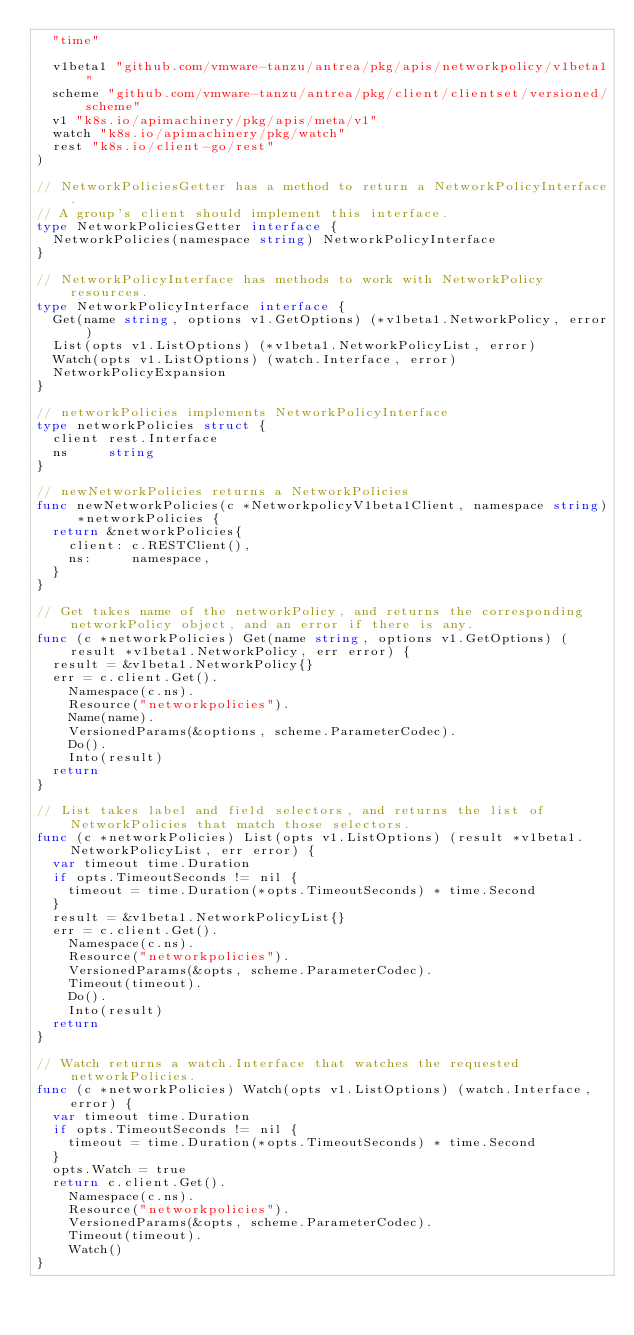<code> <loc_0><loc_0><loc_500><loc_500><_Go_>	"time"

	v1beta1 "github.com/vmware-tanzu/antrea/pkg/apis/networkpolicy/v1beta1"
	scheme "github.com/vmware-tanzu/antrea/pkg/client/clientset/versioned/scheme"
	v1 "k8s.io/apimachinery/pkg/apis/meta/v1"
	watch "k8s.io/apimachinery/pkg/watch"
	rest "k8s.io/client-go/rest"
)

// NetworkPoliciesGetter has a method to return a NetworkPolicyInterface.
// A group's client should implement this interface.
type NetworkPoliciesGetter interface {
	NetworkPolicies(namespace string) NetworkPolicyInterface
}

// NetworkPolicyInterface has methods to work with NetworkPolicy resources.
type NetworkPolicyInterface interface {
	Get(name string, options v1.GetOptions) (*v1beta1.NetworkPolicy, error)
	List(opts v1.ListOptions) (*v1beta1.NetworkPolicyList, error)
	Watch(opts v1.ListOptions) (watch.Interface, error)
	NetworkPolicyExpansion
}

// networkPolicies implements NetworkPolicyInterface
type networkPolicies struct {
	client rest.Interface
	ns     string
}

// newNetworkPolicies returns a NetworkPolicies
func newNetworkPolicies(c *NetworkpolicyV1beta1Client, namespace string) *networkPolicies {
	return &networkPolicies{
		client: c.RESTClient(),
		ns:     namespace,
	}
}

// Get takes name of the networkPolicy, and returns the corresponding networkPolicy object, and an error if there is any.
func (c *networkPolicies) Get(name string, options v1.GetOptions) (result *v1beta1.NetworkPolicy, err error) {
	result = &v1beta1.NetworkPolicy{}
	err = c.client.Get().
		Namespace(c.ns).
		Resource("networkpolicies").
		Name(name).
		VersionedParams(&options, scheme.ParameterCodec).
		Do().
		Into(result)
	return
}

// List takes label and field selectors, and returns the list of NetworkPolicies that match those selectors.
func (c *networkPolicies) List(opts v1.ListOptions) (result *v1beta1.NetworkPolicyList, err error) {
	var timeout time.Duration
	if opts.TimeoutSeconds != nil {
		timeout = time.Duration(*opts.TimeoutSeconds) * time.Second
	}
	result = &v1beta1.NetworkPolicyList{}
	err = c.client.Get().
		Namespace(c.ns).
		Resource("networkpolicies").
		VersionedParams(&opts, scheme.ParameterCodec).
		Timeout(timeout).
		Do().
		Into(result)
	return
}

// Watch returns a watch.Interface that watches the requested networkPolicies.
func (c *networkPolicies) Watch(opts v1.ListOptions) (watch.Interface, error) {
	var timeout time.Duration
	if opts.TimeoutSeconds != nil {
		timeout = time.Duration(*opts.TimeoutSeconds) * time.Second
	}
	opts.Watch = true
	return c.client.Get().
		Namespace(c.ns).
		Resource("networkpolicies").
		VersionedParams(&opts, scheme.ParameterCodec).
		Timeout(timeout).
		Watch()
}
</code> 